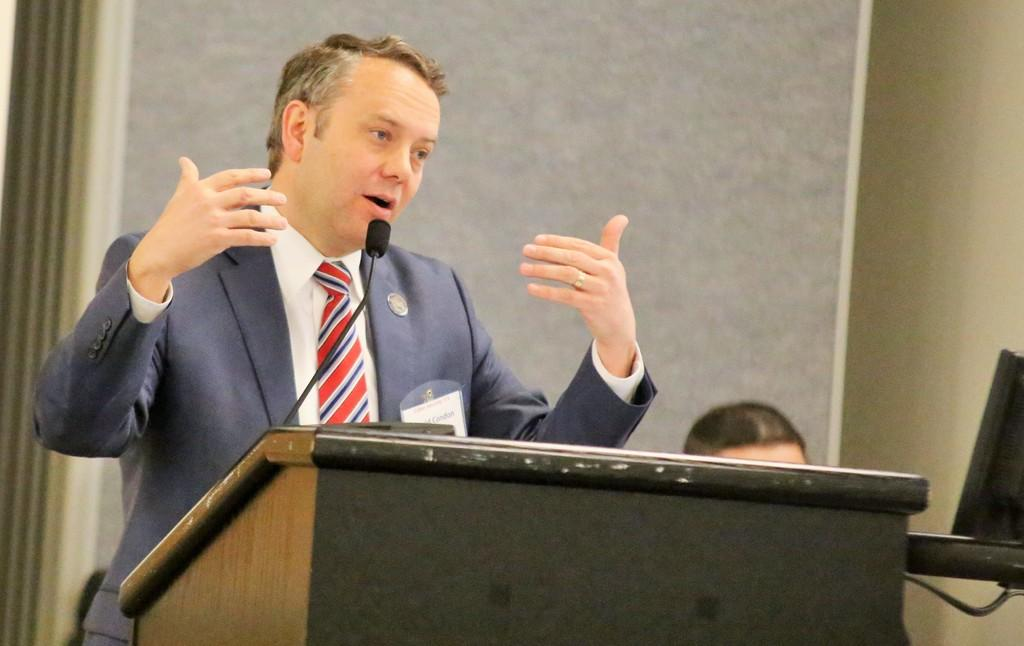Who or what can be seen in the image? There are people in the image. What is the purpose of the podium in the image? The podium in the image is likely used for presentations or speeches. What is the microphone (mic) used for in the image? The microphone (mic) is used for amplifying the speaker's voice. What is the background of the image? There is a wall in the image. Can you describe the objects in the image? There are objects in the image, but their specific details are not mentioned in the provided facts. What type of collar is visible on the person speaking at the podium? There is no collar visible on the person speaking at the podium in the image. Is there a gun present in the image? No, there is no gun present in the image. 